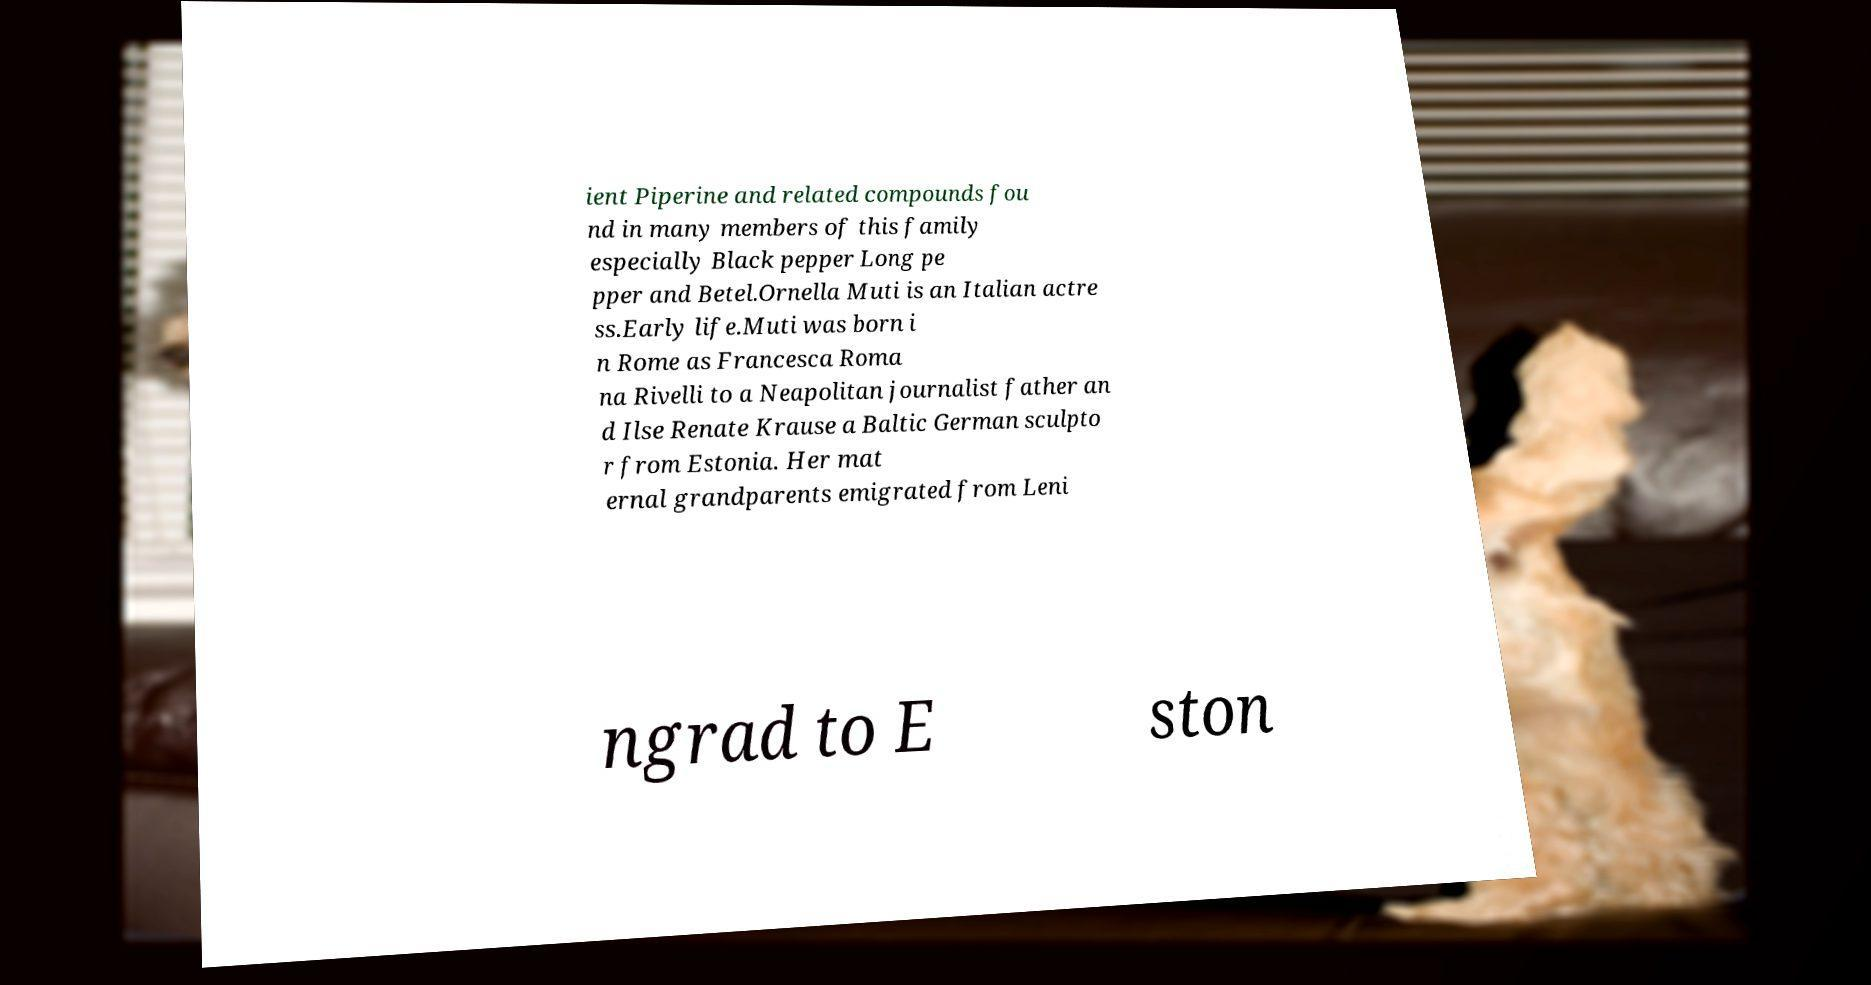I need the written content from this picture converted into text. Can you do that? ient Piperine and related compounds fou nd in many members of this family especially Black pepper Long pe pper and Betel.Ornella Muti is an Italian actre ss.Early life.Muti was born i n Rome as Francesca Roma na Rivelli to a Neapolitan journalist father an d Ilse Renate Krause a Baltic German sculpto r from Estonia. Her mat ernal grandparents emigrated from Leni ngrad to E ston 